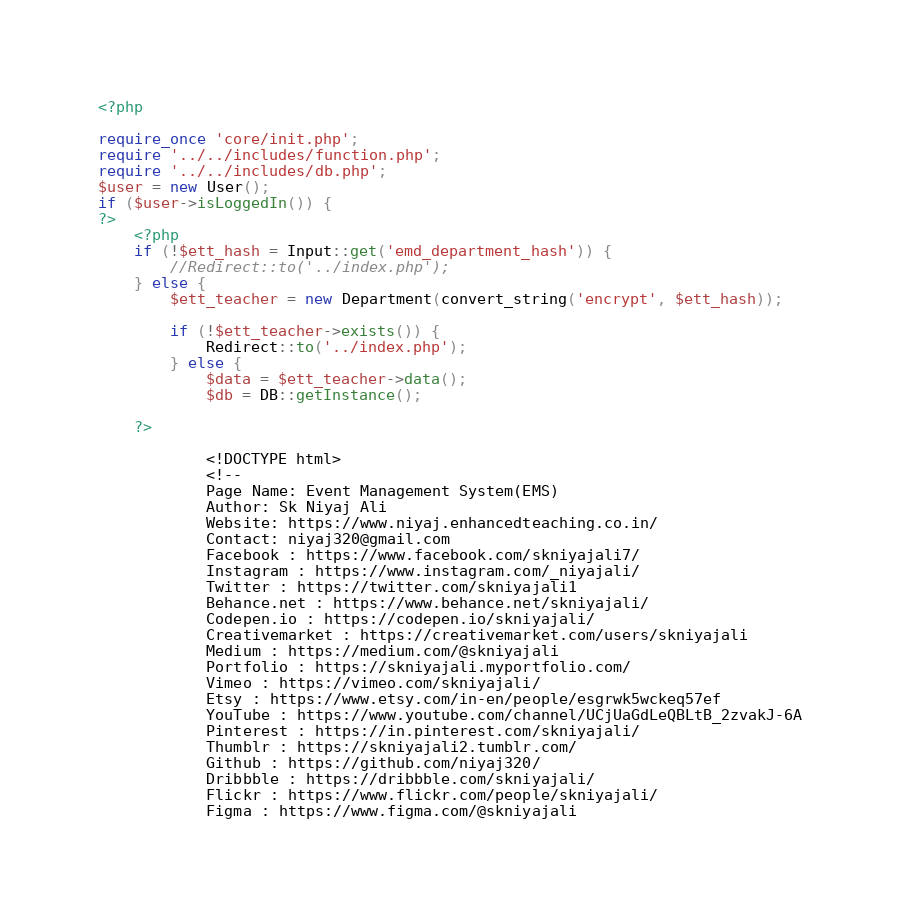Convert code to text. <code><loc_0><loc_0><loc_500><loc_500><_PHP_><?php

require_once 'core/init.php';
require '../../includes/function.php';
require '../../includes/db.php';
$user = new User();
if ($user->isLoggedIn()) {
?>
    <?php
    if (!$ett_hash = Input::get('emd_department_hash')) {
        //Redirect::to('../index.php');
    } else {
        $ett_teacher = new Department(convert_string('encrypt', $ett_hash));

        if (!$ett_teacher->exists()) {
            Redirect::to('../index.php');
        } else {
            $data = $ett_teacher->data();
            $db = DB::getInstance();

    ?>

            <!DOCTYPE html>
            <!--
            Page Name: Event Management System(EMS)
            Author: Sk Niyaj Ali
            Website: https://www.niyaj.enhancedteaching.co.in/
            Contact: niyaj320@gmail.com
            Facebook : https://www.facebook.com/skniyajali7/
            Instagram : https://www.instagram.com/_niyajali/
            Twitter : https://twitter.com/skniyajali1
            Behance.net : https://www.behance.net/skniyajali/
            Codepen.io : https://codepen.io/skniyajali/
            Creativemarket : https://creativemarket.com/users/skniyajali
            Medium : https://medium.com/@skniyajali
            Portfolio : https://skniyajali.myportfolio.com/
            Vimeo : https://vimeo.com/skniyajali/
            Etsy : https://www.etsy.com/in-en/people/esgrwk5wckeq57ef
            YouTube : https://www.youtube.com/channel/UCjUaGdLeQBLtB_2zvakJ-6A
            Pinterest : https://in.pinterest.com/skniyajali/
            Thumblr : https://skniyajali2.tumblr.com/
            Github : https://github.com/niyaj320/
            Dribbble : https://dribbble.com/skniyajali/
            Flickr : https://www.flickr.com/people/skniyajali/
            Figma : https://www.figma.com/@skniyajali</code> 